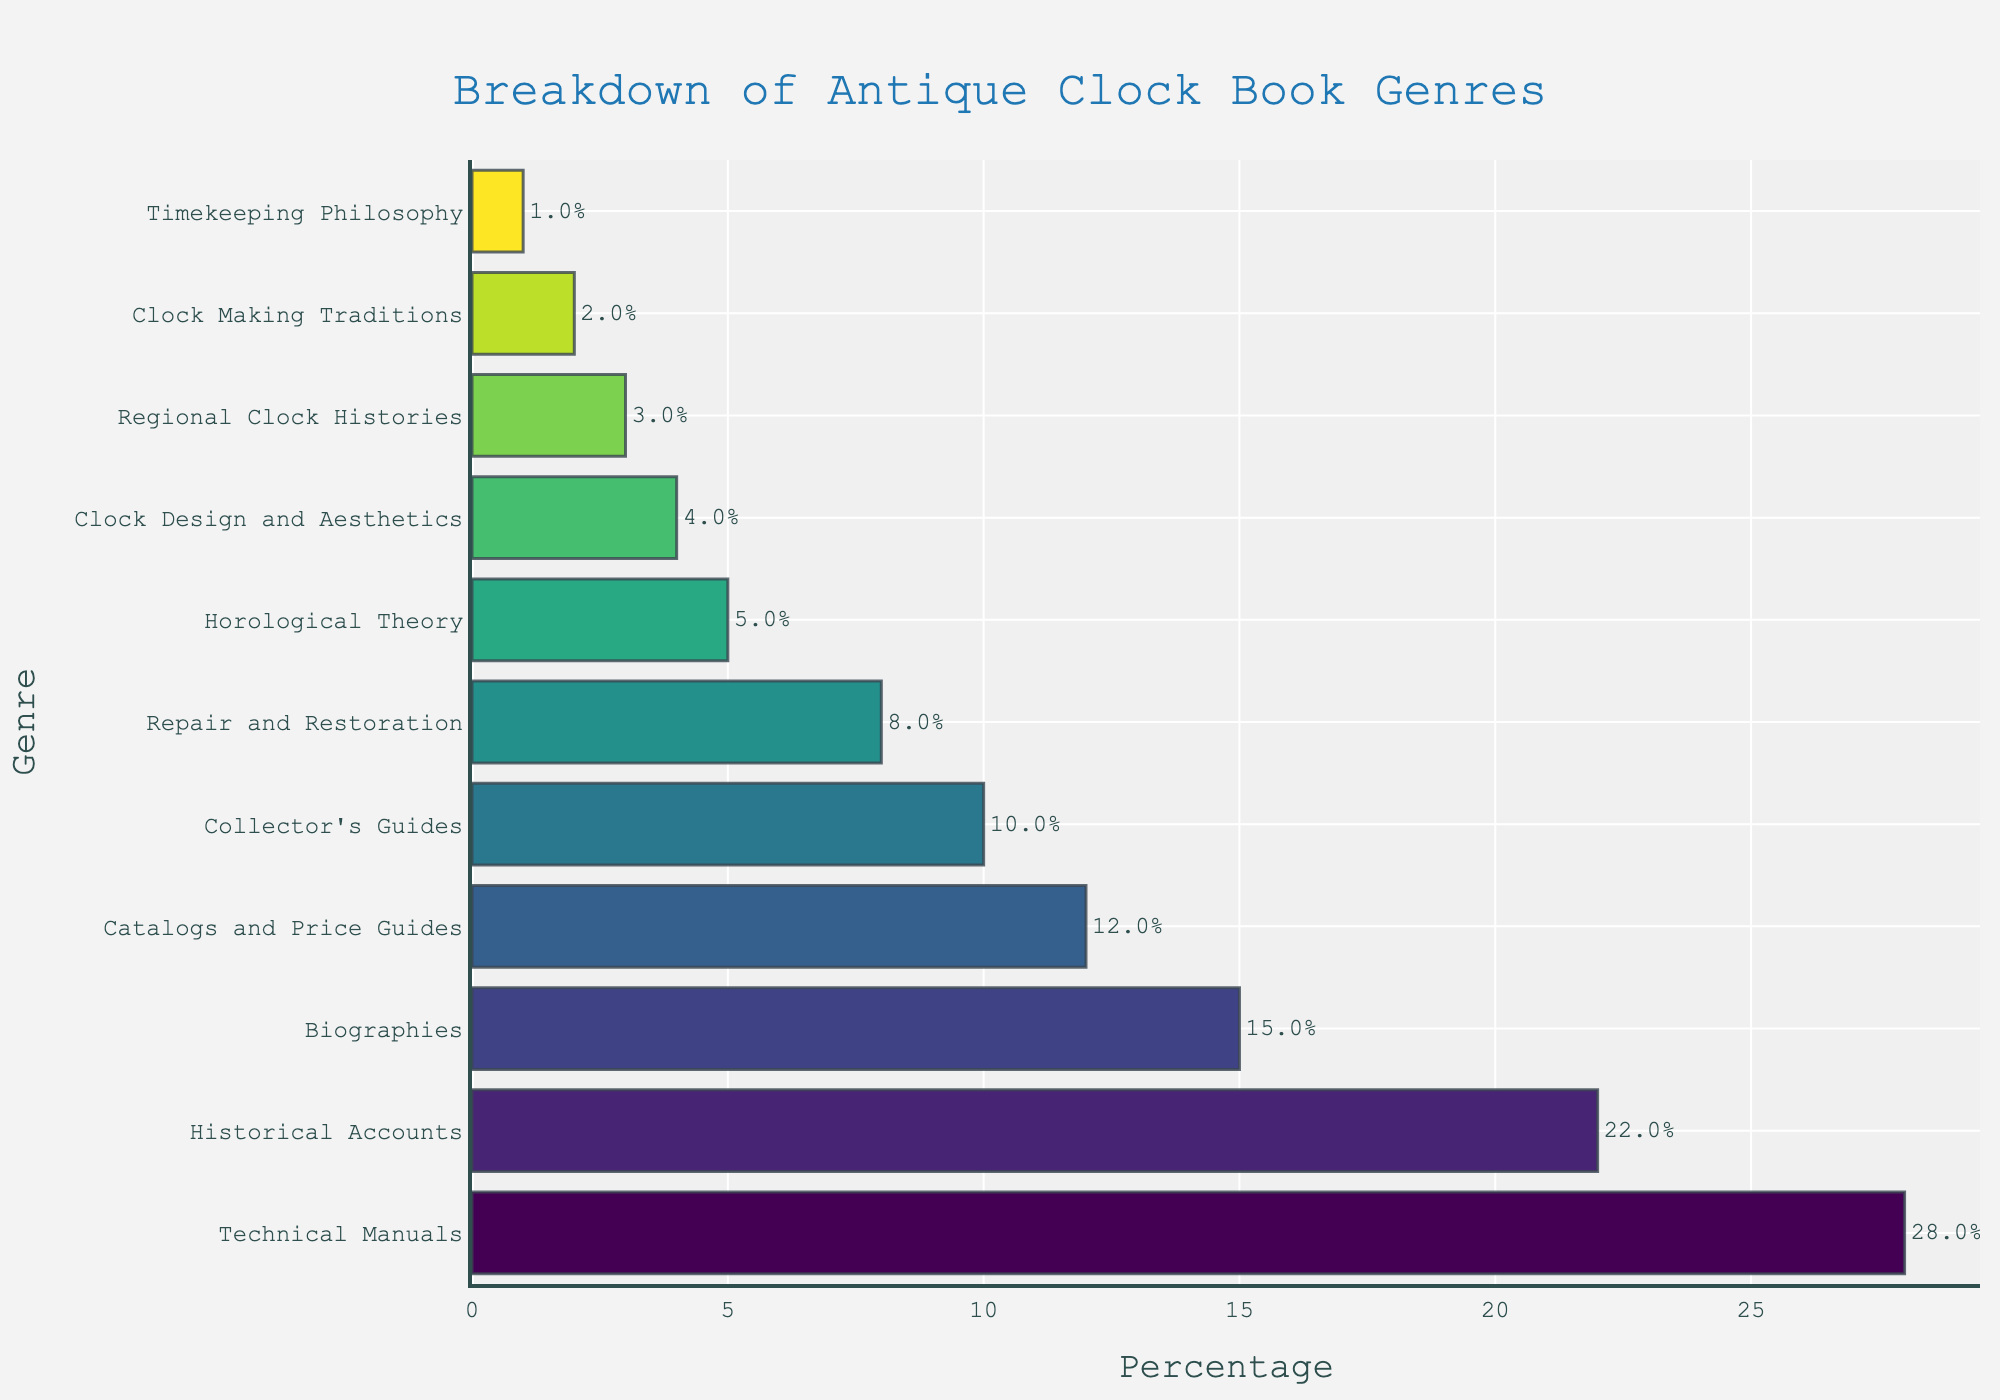What's the most common genre of antique clock books? By looking at the bar chart, the longest bar represents the genre with the highest percentage. The genre "Technical Manuals" has the longest bar.
Answer: Technical Manuals What is the combined percentage of Historical Accounts and Biographies genres? The bar chart shows the percentages for each genre. Historical Accounts are 22% and Biographies are 15%. Add them together: 22% + 15% = 37%.
Answer: 37% Which genre is less common, Collector's Guides or Repair and Restoration? Compare the lengths of the bars for each genre. Collector's Guides has a percentage of 10%, while Repair and Restoration has a percentage of 8%. Therefore, Repair and Restoration is less common.
Answer: Repair and Restoration How much more common are Technical Manuals compared to Timekeeping Philosophy? The bar for Technical Manuals shows 28%, and the bar for Timekeeping Philosophy shows 1%. Subtract 1% from 28% to find the difference: 28% - 1% = 27%.
Answer: 27% What is the total percentage of genres that are below 10%? Look at the individual percentages for genres below 10%: Repair and Restoration (8%), Horological Theory (5%), Clock Design and Aesthetics (4%), Regional Clock Histories (3%), Clock Making Traditions (2%), and Timekeeping Philosophy (1%). Add these percentages together: 8% + 5% + 4% + 3% + 2% + 1% = 23%.
Answer: 23% Which genres have a percentage higher than 15%? Look at the genres with bars longer than the 15% mark. These are Technical Manuals (28%), Historical Accounts (22%), and Biographies (15%). Since Biographies is exactly 15%, exclude it from the answer.
Answer: Technical Manuals, Historical Accounts Between Historical Accounts and Catalogs and Price Guides, which genre has a greater percentage? Compare the bar lengths for each genre. Historical Accounts has a percentage of 22%, and Catalogs and Price Guides has a percentage of 12%. Historical Accounts has a greater percentage.
Answer: Historical Accounts What is the difference in percentage between the most common and the least common genre? The most common genre is Technical Manuals (28%), and the least common genre is Timekeeping Philosophy (1%). Subtract the smallest value from the largest: 28% - 1% = 27%.
Answer: 27% In terms of visual length, which genre bar is immediately shorter than Biographies? The bar representing Biographies shows 15%. The bar just shorter is Catalogs and Price Guides, which shows 12%.
Answer: Catalogs and Price Guides What's the median percentage of all genres? To find the median, list the percentages in ascending order: 1, 2, 3, 4, 5, 8, 10, 12, 15, 22, 28. There are 11 data points, so the median is the 6th value in this sorted list: 8%.
Answer: 8% 